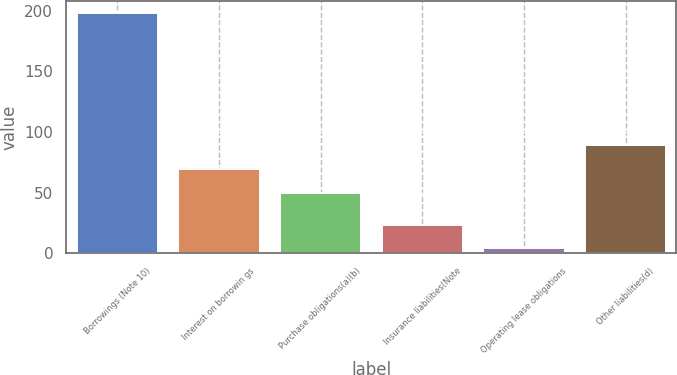Convert chart. <chart><loc_0><loc_0><loc_500><loc_500><bar_chart><fcel>Borrowings (Note 10)<fcel>Interest on borrowin gs<fcel>Purchase obligations(a)(b)<fcel>Insurance liabilities(Note<fcel>Operating lease obligations<fcel>Other liabilities(d)<nl><fcel>198.3<fcel>69.41<fcel>50<fcel>23.61<fcel>4.2<fcel>88.82<nl></chart> 